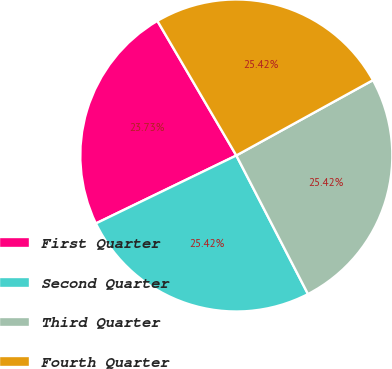Convert chart. <chart><loc_0><loc_0><loc_500><loc_500><pie_chart><fcel>First Quarter<fcel>Second Quarter<fcel>Third Quarter<fcel>Fourth Quarter<nl><fcel>23.73%<fcel>25.42%<fcel>25.42%<fcel>25.42%<nl></chart> 